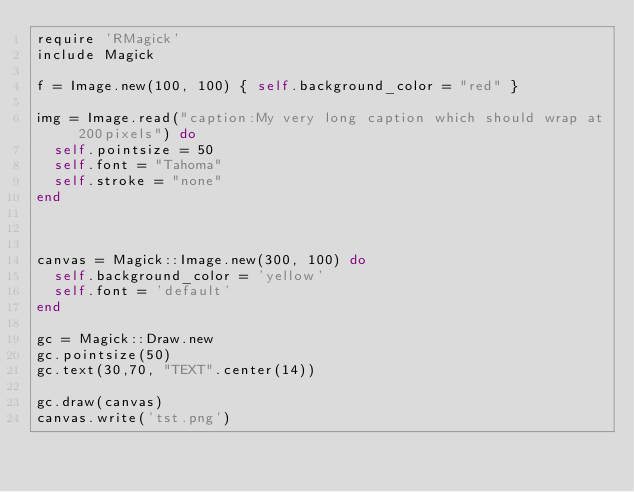<code> <loc_0><loc_0><loc_500><loc_500><_Ruby_>require 'RMagick'
include Magick

f = Image.new(100, 100) { self.background_color = "red" }

img = Image.read("caption:My very long caption which should wrap at 200pixels") do
  self.pointsize = 50
  self.font = "Tahoma"
  self.stroke = "none"
end



canvas = Magick::Image.new(300, 100) do
  self.background_color = 'yellow'
  self.font = 'default'
end

gc = Magick::Draw.new
gc.pointsize(50)
gc.text(30,70, "TEXT".center(14))

gc.draw(canvas)
canvas.write('tst.png')</code> 